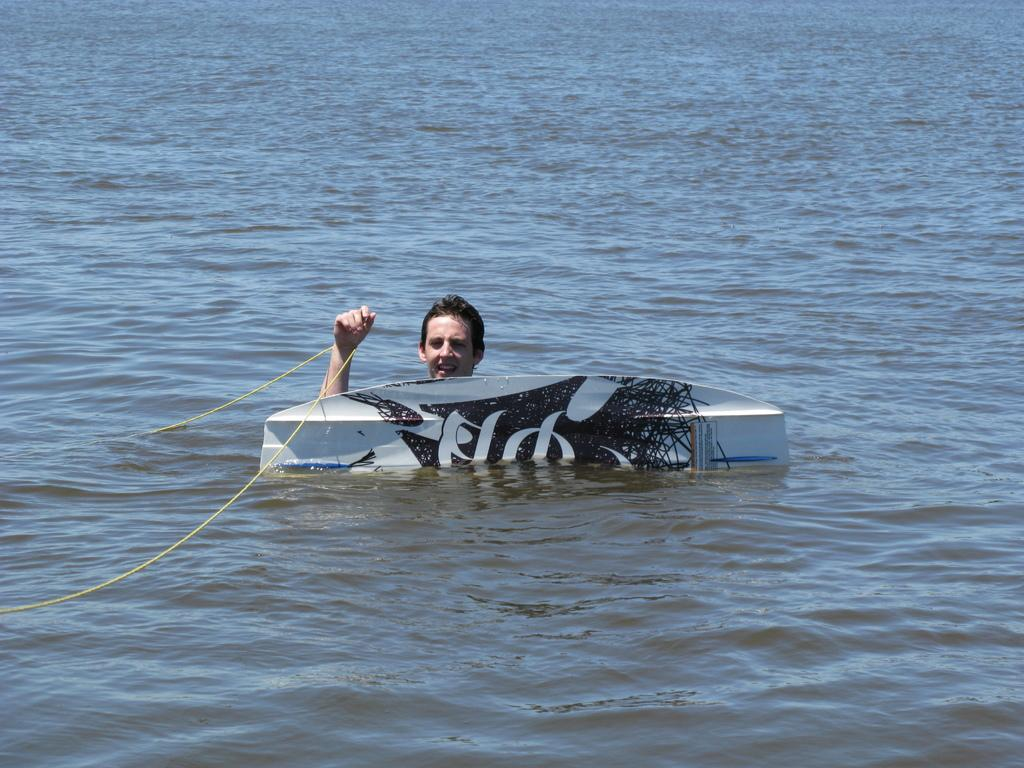Who or what is present in the image? There is a person in the image. What object can be seen in the image: Where is the person located in the image? The provided facts do not specify the location of the person in the image. What else is visible in the image besides the person? There is a rope and water visible in the image. Can you describe the unspecified object in the image? The provided facts do not specify the nature or appearance of the unspecified object in the image. What type of rifle is the person holding in the image? There is no rifle present in the image; only a person, a rope, water, and an unspecified object are visible. 